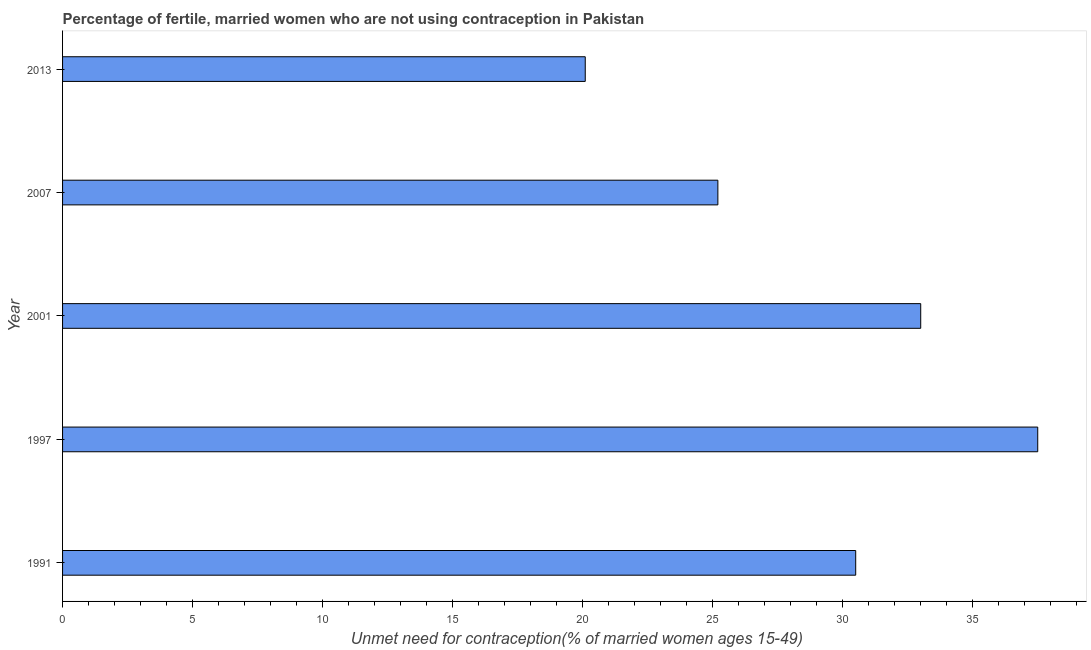Does the graph contain grids?
Keep it short and to the point. No. What is the title of the graph?
Your answer should be very brief. Percentage of fertile, married women who are not using contraception in Pakistan. What is the label or title of the X-axis?
Keep it short and to the point.  Unmet need for contraception(% of married women ages 15-49). What is the label or title of the Y-axis?
Ensure brevity in your answer.  Year. What is the number of married women who are not using contraception in 1991?
Your answer should be very brief. 30.5. Across all years, what is the maximum number of married women who are not using contraception?
Your answer should be very brief. 37.5. Across all years, what is the minimum number of married women who are not using contraception?
Offer a very short reply. 20.1. In which year was the number of married women who are not using contraception minimum?
Provide a succinct answer. 2013. What is the sum of the number of married women who are not using contraception?
Offer a terse response. 146.3. What is the difference between the number of married women who are not using contraception in 1991 and 1997?
Ensure brevity in your answer.  -7. What is the average number of married women who are not using contraception per year?
Give a very brief answer. 29.26. What is the median number of married women who are not using contraception?
Your response must be concise. 30.5. In how many years, is the number of married women who are not using contraception greater than 11 %?
Your response must be concise. 5. What is the ratio of the number of married women who are not using contraception in 1991 to that in 2001?
Ensure brevity in your answer.  0.92. Is the number of married women who are not using contraception in 1991 less than that in 2013?
Your answer should be very brief. No. What is the difference between the highest and the lowest number of married women who are not using contraception?
Your answer should be compact. 17.4. How many years are there in the graph?
Make the answer very short. 5. What is the difference between two consecutive major ticks on the X-axis?
Offer a terse response. 5. What is the  Unmet need for contraception(% of married women ages 15-49) of 1991?
Keep it short and to the point. 30.5. What is the  Unmet need for contraception(% of married women ages 15-49) of 1997?
Provide a succinct answer. 37.5. What is the  Unmet need for contraception(% of married women ages 15-49) of 2001?
Make the answer very short. 33. What is the  Unmet need for contraception(% of married women ages 15-49) in 2007?
Ensure brevity in your answer.  25.2. What is the  Unmet need for contraception(% of married women ages 15-49) in 2013?
Keep it short and to the point. 20.1. What is the difference between the  Unmet need for contraception(% of married women ages 15-49) in 1991 and 1997?
Your answer should be compact. -7. What is the difference between the  Unmet need for contraception(% of married women ages 15-49) in 1991 and 2001?
Give a very brief answer. -2.5. What is the difference between the  Unmet need for contraception(% of married women ages 15-49) in 1997 and 2007?
Keep it short and to the point. 12.3. What is the difference between the  Unmet need for contraception(% of married women ages 15-49) in 2001 and 2007?
Your response must be concise. 7.8. What is the difference between the  Unmet need for contraception(% of married women ages 15-49) in 2001 and 2013?
Give a very brief answer. 12.9. What is the ratio of the  Unmet need for contraception(% of married women ages 15-49) in 1991 to that in 1997?
Make the answer very short. 0.81. What is the ratio of the  Unmet need for contraception(% of married women ages 15-49) in 1991 to that in 2001?
Ensure brevity in your answer.  0.92. What is the ratio of the  Unmet need for contraception(% of married women ages 15-49) in 1991 to that in 2007?
Offer a very short reply. 1.21. What is the ratio of the  Unmet need for contraception(% of married women ages 15-49) in 1991 to that in 2013?
Your answer should be very brief. 1.52. What is the ratio of the  Unmet need for contraception(% of married women ages 15-49) in 1997 to that in 2001?
Provide a short and direct response. 1.14. What is the ratio of the  Unmet need for contraception(% of married women ages 15-49) in 1997 to that in 2007?
Offer a very short reply. 1.49. What is the ratio of the  Unmet need for contraception(% of married women ages 15-49) in 1997 to that in 2013?
Your answer should be very brief. 1.87. What is the ratio of the  Unmet need for contraception(% of married women ages 15-49) in 2001 to that in 2007?
Provide a succinct answer. 1.31. What is the ratio of the  Unmet need for contraception(% of married women ages 15-49) in 2001 to that in 2013?
Keep it short and to the point. 1.64. What is the ratio of the  Unmet need for contraception(% of married women ages 15-49) in 2007 to that in 2013?
Keep it short and to the point. 1.25. 